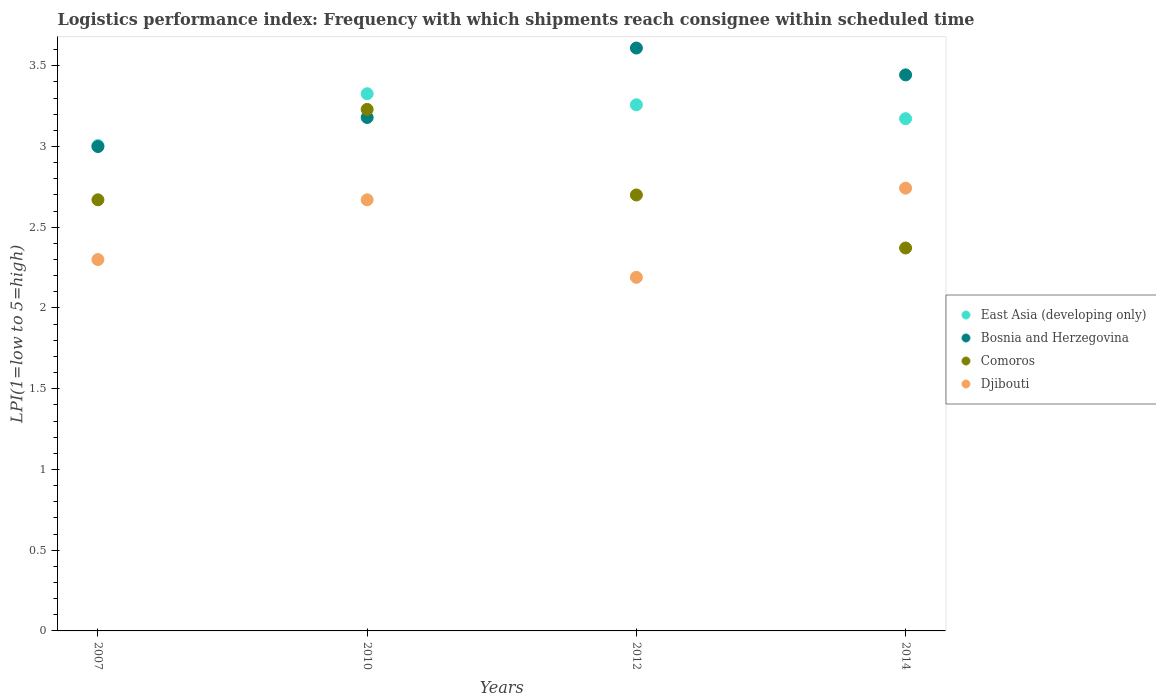How many different coloured dotlines are there?
Ensure brevity in your answer.  4. Is the number of dotlines equal to the number of legend labels?
Your answer should be very brief. Yes. What is the logistics performance index in Comoros in 2014?
Give a very brief answer. 2.37. Across all years, what is the maximum logistics performance index in Djibouti?
Provide a succinct answer. 2.74. Across all years, what is the minimum logistics performance index in Djibouti?
Your answer should be compact. 2.19. In which year was the logistics performance index in Djibouti minimum?
Offer a terse response. 2012. What is the total logistics performance index in Djibouti in the graph?
Your response must be concise. 9.9. What is the difference between the logistics performance index in Djibouti in 2010 and that in 2014?
Provide a succinct answer. -0.07. What is the difference between the logistics performance index in Bosnia and Herzegovina in 2014 and the logistics performance index in Djibouti in 2007?
Offer a very short reply. 1.14. What is the average logistics performance index in Djibouti per year?
Offer a very short reply. 2.48. In the year 2007, what is the difference between the logistics performance index in East Asia (developing only) and logistics performance index in Comoros?
Ensure brevity in your answer.  0.34. In how many years, is the logistics performance index in Djibouti greater than 0.2?
Your answer should be compact. 4. What is the ratio of the logistics performance index in East Asia (developing only) in 2007 to that in 2010?
Ensure brevity in your answer.  0.9. Is the logistics performance index in Bosnia and Herzegovina in 2007 less than that in 2010?
Ensure brevity in your answer.  Yes. What is the difference between the highest and the second highest logistics performance index in Comoros?
Keep it short and to the point. 0.53. What is the difference between the highest and the lowest logistics performance index in Comoros?
Offer a very short reply. 0.86. In how many years, is the logistics performance index in Comoros greater than the average logistics performance index in Comoros taken over all years?
Your response must be concise. 1. Is the sum of the logistics performance index in Bosnia and Herzegovina in 2010 and 2012 greater than the maximum logistics performance index in East Asia (developing only) across all years?
Offer a very short reply. Yes. Is it the case that in every year, the sum of the logistics performance index in East Asia (developing only) and logistics performance index in Djibouti  is greater than the logistics performance index in Comoros?
Provide a short and direct response. Yes. Is the logistics performance index in East Asia (developing only) strictly greater than the logistics performance index in Djibouti over the years?
Offer a terse response. Yes. Is the logistics performance index in East Asia (developing only) strictly less than the logistics performance index in Djibouti over the years?
Make the answer very short. No. How many dotlines are there?
Provide a succinct answer. 4. How are the legend labels stacked?
Your answer should be very brief. Vertical. What is the title of the graph?
Keep it short and to the point. Logistics performance index: Frequency with which shipments reach consignee within scheduled time. What is the label or title of the Y-axis?
Offer a very short reply. LPI(1=low to 5=high). What is the LPI(1=low to 5=high) in East Asia (developing only) in 2007?
Keep it short and to the point. 3.01. What is the LPI(1=low to 5=high) of Bosnia and Herzegovina in 2007?
Offer a very short reply. 3. What is the LPI(1=low to 5=high) of Comoros in 2007?
Keep it short and to the point. 2.67. What is the LPI(1=low to 5=high) in Djibouti in 2007?
Keep it short and to the point. 2.3. What is the LPI(1=low to 5=high) in East Asia (developing only) in 2010?
Provide a succinct answer. 3.33. What is the LPI(1=low to 5=high) of Bosnia and Herzegovina in 2010?
Keep it short and to the point. 3.18. What is the LPI(1=low to 5=high) in Comoros in 2010?
Ensure brevity in your answer.  3.23. What is the LPI(1=low to 5=high) of Djibouti in 2010?
Provide a succinct answer. 2.67. What is the LPI(1=low to 5=high) of East Asia (developing only) in 2012?
Keep it short and to the point. 3.26. What is the LPI(1=low to 5=high) of Bosnia and Herzegovina in 2012?
Your answer should be compact. 3.61. What is the LPI(1=low to 5=high) of Comoros in 2012?
Give a very brief answer. 2.7. What is the LPI(1=low to 5=high) in Djibouti in 2012?
Offer a very short reply. 2.19. What is the LPI(1=low to 5=high) in East Asia (developing only) in 2014?
Your answer should be compact. 3.17. What is the LPI(1=low to 5=high) of Bosnia and Herzegovina in 2014?
Your answer should be compact. 3.44. What is the LPI(1=low to 5=high) in Comoros in 2014?
Your answer should be very brief. 2.37. What is the LPI(1=low to 5=high) of Djibouti in 2014?
Your answer should be compact. 2.74. Across all years, what is the maximum LPI(1=low to 5=high) in East Asia (developing only)?
Provide a short and direct response. 3.33. Across all years, what is the maximum LPI(1=low to 5=high) of Bosnia and Herzegovina?
Provide a short and direct response. 3.61. Across all years, what is the maximum LPI(1=low to 5=high) of Comoros?
Keep it short and to the point. 3.23. Across all years, what is the maximum LPI(1=low to 5=high) in Djibouti?
Make the answer very short. 2.74. Across all years, what is the minimum LPI(1=low to 5=high) of East Asia (developing only)?
Your response must be concise. 3.01. Across all years, what is the minimum LPI(1=low to 5=high) of Bosnia and Herzegovina?
Your response must be concise. 3. Across all years, what is the minimum LPI(1=low to 5=high) in Comoros?
Your answer should be very brief. 2.37. Across all years, what is the minimum LPI(1=low to 5=high) in Djibouti?
Provide a succinct answer. 2.19. What is the total LPI(1=low to 5=high) of East Asia (developing only) in the graph?
Provide a succinct answer. 12.76. What is the total LPI(1=low to 5=high) in Bosnia and Herzegovina in the graph?
Your answer should be very brief. 13.23. What is the total LPI(1=low to 5=high) in Comoros in the graph?
Ensure brevity in your answer.  10.97. What is the total LPI(1=low to 5=high) in Djibouti in the graph?
Offer a very short reply. 9.9. What is the difference between the LPI(1=low to 5=high) of East Asia (developing only) in 2007 and that in 2010?
Your answer should be compact. -0.32. What is the difference between the LPI(1=low to 5=high) in Bosnia and Herzegovina in 2007 and that in 2010?
Offer a terse response. -0.18. What is the difference between the LPI(1=low to 5=high) in Comoros in 2007 and that in 2010?
Ensure brevity in your answer.  -0.56. What is the difference between the LPI(1=low to 5=high) in Djibouti in 2007 and that in 2010?
Ensure brevity in your answer.  -0.37. What is the difference between the LPI(1=low to 5=high) in East Asia (developing only) in 2007 and that in 2012?
Give a very brief answer. -0.25. What is the difference between the LPI(1=low to 5=high) in Bosnia and Herzegovina in 2007 and that in 2012?
Give a very brief answer. -0.61. What is the difference between the LPI(1=low to 5=high) in Comoros in 2007 and that in 2012?
Offer a very short reply. -0.03. What is the difference between the LPI(1=low to 5=high) in Djibouti in 2007 and that in 2012?
Ensure brevity in your answer.  0.11. What is the difference between the LPI(1=low to 5=high) of East Asia (developing only) in 2007 and that in 2014?
Your response must be concise. -0.17. What is the difference between the LPI(1=low to 5=high) of Bosnia and Herzegovina in 2007 and that in 2014?
Make the answer very short. -0.44. What is the difference between the LPI(1=low to 5=high) of Comoros in 2007 and that in 2014?
Your answer should be very brief. 0.3. What is the difference between the LPI(1=low to 5=high) of Djibouti in 2007 and that in 2014?
Give a very brief answer. -0.44. What is the difference between the LPI(1=low to 5=high) of East Asia (developing only) in 2010 and that in 2012?
Your answer should be very brief. 0.07. What is the difference between the LPI(1=low to 5=high) in Bosnia and Herzegovina in 2010 and that in 2012?
Provide a short and direct response. -0.43. What is the difference between the LPI(1=low to 5=high) of Comoros in 2010 and that in 2012?
Offer a very short reply. 0.53. What is the difference between the LPI(1=low to 5=high) in Djibouti in 2010 and that in 2012?
Make the answer very short. 0.48. What is the difference between the LPI(1=low to 5=high) of East Asia (developing only) in 2010 and that in 2014?
Offer a terse response. 0.15. What is the difference between the LPI(1=low to 5=high) in Bosnia and Herzegovina in 2010 and that in 2014?
Your answer should be compact. -0.26. What is the difference between the LPI(1=low to 5=high) of Comoros in 2010 and that in 2014?
Your answer should be very brief. 0.86. What is the difference between the LPI(1=low to 5=high) of Djibouti in 2010 and that in 2014?
Your answer should be compact. -0.07. What is the difference between the LPI(1=low to 5=high) of East Asia (developing only) in 2012 and that in 2014?
Offer a terse response. 0.09. What is the difference between the LPI(1=low to 5=high) of Bosnia and Herzegovina in 2012 and that in 2014?
Keep it short and to the point. 0.17. What is the difference between the LPI(1=low to 5=high) of Comoros in 2012 and that in 2014?
Your response must be concise. 0.33. What is the difference between the LPI(1=low to 5=high) in Djibouti in 2012 and that in 2014?
Offer a very short reply. -0.55. What is the difference between the LPI(1=low to 5=high) of East Asia (developing only) in 2007 and the LPI(1=low to 5=high) of Bosnia and Herzegovina in 2010?
Your answer should be very brief. -0.17. What is the difference between the LPI(1=low to 5=high) in East Asia (developing only) in 2007 and the LPI(1=low to 5=high) in Comoros in 2010?
Your response must be concise. -0.22. What is the difference between the LPI(1=low to 5=high) of East Asia (developing only) in 2007 and the LPI(1=low to 5=high) of Djibouti in 2010?
Ensure brevity in your answer.  0.34. What is the difference between the LPI(1=low to 5=high) in Bosnia and Herzegovina in 2007 and the LPI(1=low to 5=high) in Comoros in 2010?
Your answer should be very brief. -0.23. What is the difference between the LPI(1=low to 5=high) in Bosnia and Herzegovina in 2007 and the LPI(1=low to 5=high) in Djibouti in 2010?
Provide a short and direct response. 0.33. What is the difference between the LPI(1=low to 5=high) in Comoros in 2007 and the LPI(1=low to 5=high) in Djibouti in 2010?
Provide a short and direct response. 0. What is the difference between the LPI(1=low to 5=high) in East Asia (developing only) in 2007 and the LPI(1=low to 5=high) in Bosnia and Herzegovina in 2012?
Your answer should be very brief. -0.6. What is the difference between the LPI(1=low to 5=high) of East Asia (developing only) in 2007 and the LPI(1=low to 5=high) of Comoros in 2012?
Your answer should be compact. 0.31. What is the difference between the LPI(1=low to 5=high) in East Asia (developing only) in 2007 and the LPI(1=low to 5=high) in Djibouti in 2012?
Ensure brevity in your answer.  0.82. What is the difference between the LPI(1=low to 5=high) in Bosnia and Herzegovina in 2007 and the LPI(1=low to 5=high) in Comoros in 2012?
Your answer should be very brief. 0.3. What is the difference between the LPI(1=low to 5=high) of Bosnia and Herzegovina in 2007 and the LPI(1=low to 5=high) of Djibouti in 2012?
Give a very brief answer. 0.81. What is the difference between the LPI(1=low to 5=high) in Comoros in 2007 and the LPI(1=low to 5=high) in Djibouti in 2012?
Ensure brevity in your answer.  0.48. What is the difference between the LPI(1=low to 5=high) in East Asia (developing only) in 2007 and the LPI(1=low to 5=high) in Bosnia and Herzegovina in 2014?
Your answer should be compact. -0.44. What is the difference between the LPI(1=low to 5=high) of East Asia (developing only) in 2007 and the LPI(1=low to 5=high) of Comoros in 2014?
Keep it short and to the point. 0.63. What is the difference between the LPI(1=low to 5=high) of East Asia (developing only) in 2007 and the LPI(1=low to 5=high) of Djibouti in 2014?
Provide a succinct answer. 0.26. What is the difference between the LPI(1=low to 5=high) of Bosnia and Herzegovina in 2007 and the LPI(1=low to 5=high) of Comoros in 2014?
Make the answer very short. 0.63. What is the difference between the LPI(1=low to 5=high) in Bosnia and Herzegovina in 2007 and the LPI(1=low to 5=high) in Djibouti in 2014?
Offer a very short reply. 0.26. What is the difference between the LPI(1=low to 5=high) of Comoros in 2007 and the LPI(1=low to 5=high) of Djibouti in 2014?
Offer a very short reply. -0.07. What is the difference between the LPI(1=low to 5=high) of East Asia (developing only) in 2010 and the LPI(1=low to 5=high) of Bosnia and Herzegovina in 2012?
Keep it short and to the point. -0.28. What is the difference between the LPI(1=low to 5=high) in East Asia (developing only) in 2010 and the LPI(1=low to 5=high) in Comoros in 2012?
Offer a terse response. 0.63. What is the difference between the LPI(1=low to 5=high) of East Asia (developing only) in 2010 and the LPI(1=low to 5=high) of Djibouti in 2012?
Keep it short and to the point. 1.14. What is the difference between the LPI(1=low to 5=high) of Bosnia and Herzegovina in 2010 and the LPI(1=low to 5=high) of Comoros in 2012?
Ensure brevity in your answer.  0.48. What is the difference between the LPI(1=low to 5=high) in Bosnia and Herzegovina in 2010 and the LPI(1=low to 5=high) in Djibouti in 2012?
Give a very brief answer. 0.99. What is the difference between the LPI(1=low to 5=high) of Comoros in 2010 and the LPI(1=low to 5=high) of Djibouti in 2012?
Give a very brief answer. 1.04. What is the difference between the LPI(1=low to 5=high) of East Asia (developing only) in 2010 and the LPI(1=low to 5=high) of Bosnia and Herzegovina in 2014?
Your response must be concise. -0.12. What is the difference between the LPI(1=low to 5=high) of East Asia (developing only) in 2010 and the LPI(1=low to 5=high) of Comoros in 2014?
Provide a succinct answer. 0.96. What is the difference between the LPI(1=low to 5=high) of East Asia (developing only) in 2010 and the LPI(1=low to 5=high) of Djibouti in 2014?
Your answer should be very brief. 0.58. What is the difference between the LPI(1=low to 5=high) in Bosnia and Herzegovina in 2010 and the LPI(1=low to 5=high) in Comoros in 2014?
Your answer should be compact. 0.81. What is the difference between the LPI(1=low to 5=high) in Bosnia and Herzegovina in 2010 and the LPI(1=low to 5=high) in Djibouti in 2014?
Offer a very short reply. 0.44. What is the difference between the LPI(1=low to 5=high) of Comoros in 2010 and the LPI(1=low to 5=high) of Djibouti in 2014?
Your answer should be compact. 0.49. What is the difference between the LPI(1=low to 5=high) in East Asia (developing only) in 2012 and the LPI(1=low to 5=high) in Bosnia and Herzegovina in 2014?
Ensure brevity in your answer.  -0.19. What is the difference between the LPI(1=low to 5=high) of East Asia (developing only) in 2012 and the LPI(1=low to 5=high) of Comoros in 2014?
Ensure brevity in your answer.  0.89. What is the difference between the LPI(1=low to 5=high) in East Asia (developing only) in 2012 and the LPI(1=low to 5=high) in Djibouti in 2014?
Your answer should be compact. 0.52. What is the difference between the LPI(1=low to 5=high) in Bosnia and Herzegovina in 2012 and the LPI(1=low to 5=high) in Comoros in 2014?
Make the answer very short. 1.24. What is the difference between the LPI(1=low to 5=high) of Bosnia and Herzegovina in 2012 and the LPI(1=low to 5=high) of Djibouti in 2014?
Give a very brief answer. 0.87. What is the difference between the LPI(1=low to 5=high) of Comoros in 2012 and the LPI(1=low to 5=high) of Djibouti in 2014?
Give a very brief answer. -0.04. What is the average LPI(1=low to 5=high) in East Asia (developing only) per year?
Offer a terse response. 3.19. What is the average LPI(1=low to 5=high) of Bosnia and Herzegovina per year?
Give a very brief answer. 3.31. What is the average LPI(1=low to 5=high) of Comoros per year?
Provide a short and direct response. 2.74. What is the average LPI(1=low to 5=high) of Djibouti per year?
Offer a very short reply. 2.48. In the year 2007, what is the difference between the LPI(1=low to 5=high) of East Asia (developing only) and LPI(1=low to 5=high) of Bosnia and Herzegovina?
Your answer should be compact. 0.01. In the year 2007, what is the difference between the LPI(1=low to 5=high) in East Asia (developing only) and LPI(1=low to 5=high) in Comoros?
Keep it short and to the point. 0.34. In the year 2007, what is the difference between the LPI(1=low to 5=high) of East Asia (developing only) and LPI(1=low to 5=high) of Djibouti?
Offer a terse response. 0.71. In the year 2007, what is the difference between the LPI(1=low to 5=high) in Bosnia and Herzegovina and LPI(1=low to 5=high) in Comoros?
Make the answer very short. 0.33. In the year 2007, what is the difference between the LPI(1=low to 5=high) in Comoros and LPI(1=low to 5=high) in Djibouti?
Give a very brief answer. 0.37. In the year 2010, what is the difference between the LPI(1=low to 5=high) of East Asia (developing only) and LPI(1=low to 5=high) of Bosnia and Herzegovina?
Provide a succinct answer. 0.15. In the year 2010, what is the difference between the LPI(1=low to 5=high) of East Asia (developing only) and LPI(1=low to 5=high) of Comoros?
Provide a short and direct response. 0.1. In the year 2010, what is the difference between the LPI(1=low to 5=high) of East Asia (developing only) and LPI(1=low to 5=high) of Djibouti?
Provide a succinct answer. 0.66. In the year 2010, what is the difference between the LPI(1=low to 5=high) in Bosnia and Herzegovina and LPI(1=low to 5=high) in Comoros?
Your response must be concise. -0.05. In the year 2010, what is the difference between the LPI(1=low to 5=high) in Bosnia and Herzegovina and LPI(1=low to 5=high) in Djibouti?
Offer a very short reply. 0.51. In the year 2010, what is the difference between the LPI(1=low to 5=high) of Comoros and LPI(1=low to 5=high) of Djibouti?
Your response must be concise. 0.56. In the year 2012, what is the difference between the LPI(1=low to 5=high) of East Asia (developing only) and LPI(1=low to 5=high) of Bosnia and Herzegovina?
Offer a very short reply. -0.35. In the year 2012, what is the difference between the LPI(1=low to 5=high) of East Asia (developing only) and LPI(1=low to 5=high) of Comoros?
Your answer should be very brief. 0.56. In the year 2012, what is the difference between the LPI(1=low to 5=high) of East Asia (developing only) and LPI(1=low to 5=high) of Djibouti?
Offer a terse response. 1.07. In the year 2012, what is the difference between the LPI(1=low to 5=high) in Bosnia and Herzegovina and LPI(1=low to 5=high) in Comoros?
Offer a terse response. 0.91. In the year 2012, what is the difference between the LPI(1=low to 5=high) in Bosnia and Herzegovina and LPI(1=low to 5=high) in Djibouti?
Ensure brevity in your answer.  1.42. In the year 2012, what is the difference between the LPI(1=low to 5=high) in Comoros and LPI(1=low to 5=high) in Djibouti?
Offer a terse response. 0.51. In the year 2014, what is the difference between the LPI(1=low to 5=high) of East Asia (developing only) and LPI(1=low to 5=high) of Bosnia and Herzegovina?
Offer a terse response. -0.27. In the year 2014, what is the difference between the LPI(1=low to 5=high) of East Asia (developing only) and LPI(1=low to 5=high) of Comoros?
Keep it short and to the point. 0.8. In the year 2014, what is the difference between the LPI(1=low to 5=high) of East Asia (developing only) and LPI(1=low to 5=high) of Djibouti?
Provide a short and direct response. 0.43. In the year 2014, what is the difference between the LPI(1=low to 5=high) in Bosnia and Herzegovina and LPI(1=low to 5=high) in Comoros?
Your answer should be very brief. 1.07. In the year 2014, what is the difference between the LPI(1=low to 5=high) in Bosnia and Herzegovina and LPI(1=low to 5=high) in Djibouti?
Keep it short and to the point. 0.7. In the year 2014, what is the difference between the LPI(1=low to 5=high) of Comoros and LPI(1=low to 5=high) of Djibouti?
Provide a short and direct response. -0.37. What is the ratio of the LPI(1=low to 5=high) of East Asia (developing only) in 2007 to that in 2010?
Provide a succinct answer. 0.9. What is the ratio of the LPI(1=low to 5=high) in Bosnia and Herzegovina in 2007 to that in 2010?
Give a very brief answer. 0.94. What is the ratio of the LPI(1=low to 5=high) in Comoros in 2007 to that in 2010?
Provide a succinct answer. 0.83. What is the ratio of the LPI(1=low to 5=high) in Djibouti in 2007 to that in 2010?
Give a very brief answer. 0.86. What is the ratio of the LPI(1=low to 5=high) in East Asia (developing only) in 2007 to that in 2012?
Your response must be concise. 0.92. What is the ratio of the LPI(1=low to 5=high) of Bosnia and Herzegovina in 2007 to that in 2012?
Provide a succinct answer. 0.83. What is the ratio of the LPI(1=low to 5=high) of Comoros in 2007 to that in 2012?
Ensure brevity in your answer.  0.99. What is the ratio of the LPI(1=low to 5=high) in Djibouti in 2007 to that in 2012?
Provide a succinct answer. 1.05. What is the ratio of the LPI(1=low to 5=high) in East Asia (developing only) in 2007 to that in 2014?
Keep it short and to the point. 0.95. What is the ratio of the LPI(1=low to 5=high) in Bosnia and Herzegovina in 2007 to that in 2014?
Give a very brief answer. 0.87. What is the ratio of the LPI(1=low to 5=high) of Comoros in 2007 to that in 2014?
Your answer should be very brief. 1.13. What is the ratio of the LPI(1=low to 5=high) of Djibouti in 2007 to that in 2014?
Provide a short and direct response. 0.84. What is the ratio of the LPI(1=low to 5=high) in Bosnia and Herzegovina in 2010 to that in 2012?
Ensure brevity in your answer.  0.88. What is the ratio of the LPI(1=low to 5=high) of Comoros in 2010 to that in 2012?
Offer a very short reply. 1.2. What is the ratio of the LPI(1=low to 5=high) in Djibouti in 2010 to that in 2012?
Provide a succinct answer. 1.22. What is the ratio of the LPI(1=low to 5=high) of East Asia (developing only) in 2010 to that in 2014?
Your answer should be compact. 1.05. What is the ratio of the LPI(1=low to 5=high) of Bosnia and Herzegovina in 2010 to that in 2014?
Your answer should be very brief. 0.92. What is the ratio of the LPI(1=low to 5=high) of Comoros in 2010 to that in 2014?
Your response must be concise. 1.36. What is the ratio of the LPI(1=low to 5=high) in Djibouti in 2010 to that in 2014?
Offer a terse response. 0.97. What is the ratio of the LPI(1=low to 5=high) of East Asia (developing only) in 2012 to that in 2014?
Ensure brevity in your answer.  1.03. What is the ratio of the LPI(1=low to 5=high) of Bosnia and Herzegovina in 2012 to that in 2014?
Offer a terse response. 1.05. What is the ratio of the LPI(1=low to 5=high) in Comoros in 2012 to that in 2014?
Provide a succinct answer. 1.14. What is the ratio of the LPI(1=low to 5=high) in Djibouti in 2012 to that in 2014?
Offer a terse response. 0.8. What is the difference between the highest and the second highest LPI(1=low to 5=high) in East Asia (developing only)?
Offer a very short reply. 0.07. What is the difference between the highest and the second highest LPI(1=low to 5=high) of Bosnia and Herzegovina?
Your answer should be compact. 0.17. What is the difference between the highest and the second highest LPI(1=low to 5=high) in Comoros?
Keep it short and to the point. 0.53. What is the difference between the highest and the second highest LPI(1=low to 5=high) of Djibouti?
Make the answer very short. 0.07. What is the difference between the highest and the lowest LPI(1=low to 5=high) of East Asia (developing only)?
Give a very brief answer. 0.32. What is the difference between the highest and the lowest LPI(1=low to 5=high) in Bosnia and Herzegovina?
Give a very brief answer. 0.61. What is the difference between the highest and the lowest LPI(1=low to 5=high) of Comoros?
Provide a succinct answer. 0.86. What is the difference between the highest and the lowest LPI(1=low to 5=high) in Djibouti?
Provide a short and direct response. 0.55. 